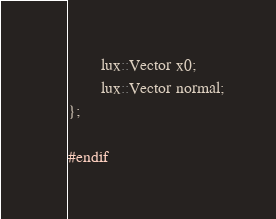<code> <loc_0><loc_0><loc_500><loc_500><_C_>		lux::Vector x0;
		lux::Vector normal;
};

#endif
</code> 